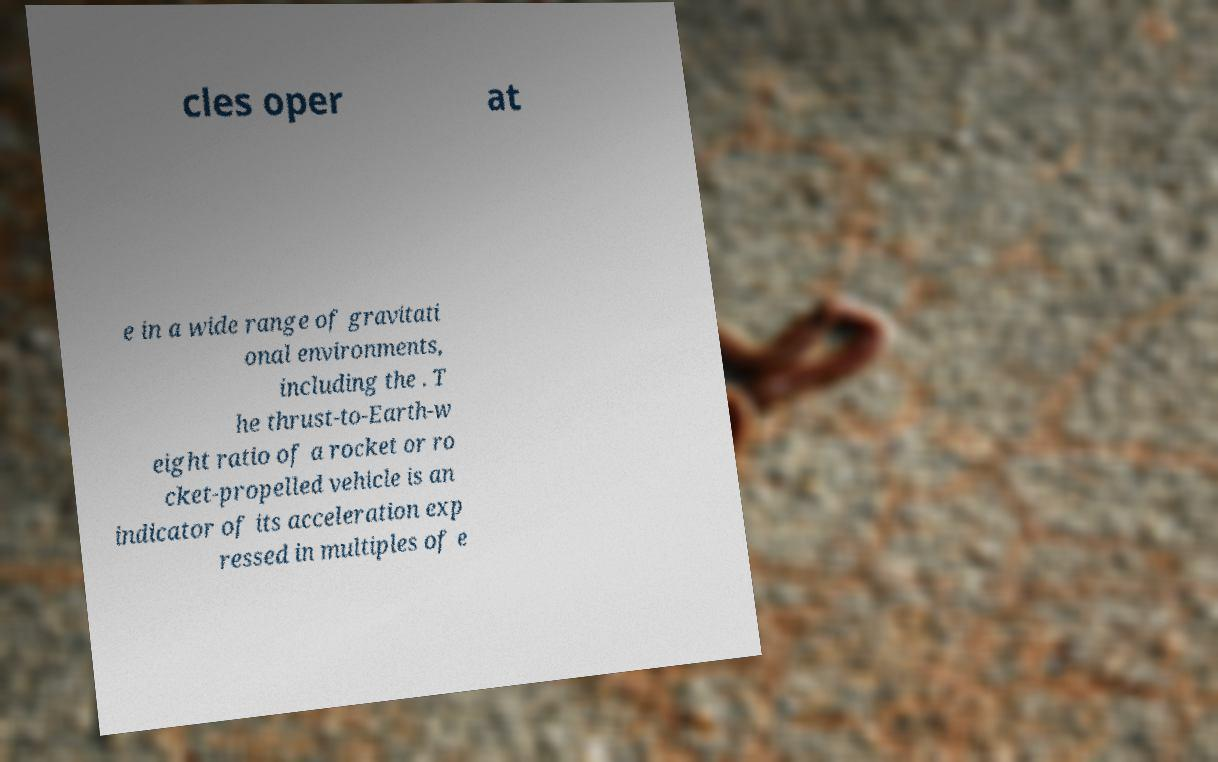Could you extract and type out the text from this image? cles oper at e in a wide range of gravitati onal environments, including the . T he thrust-to-Earth-w eight ratio of a rocket or ro cket-propelled vehicle is an indicator of its acceleration exp ressed in multiples of e 